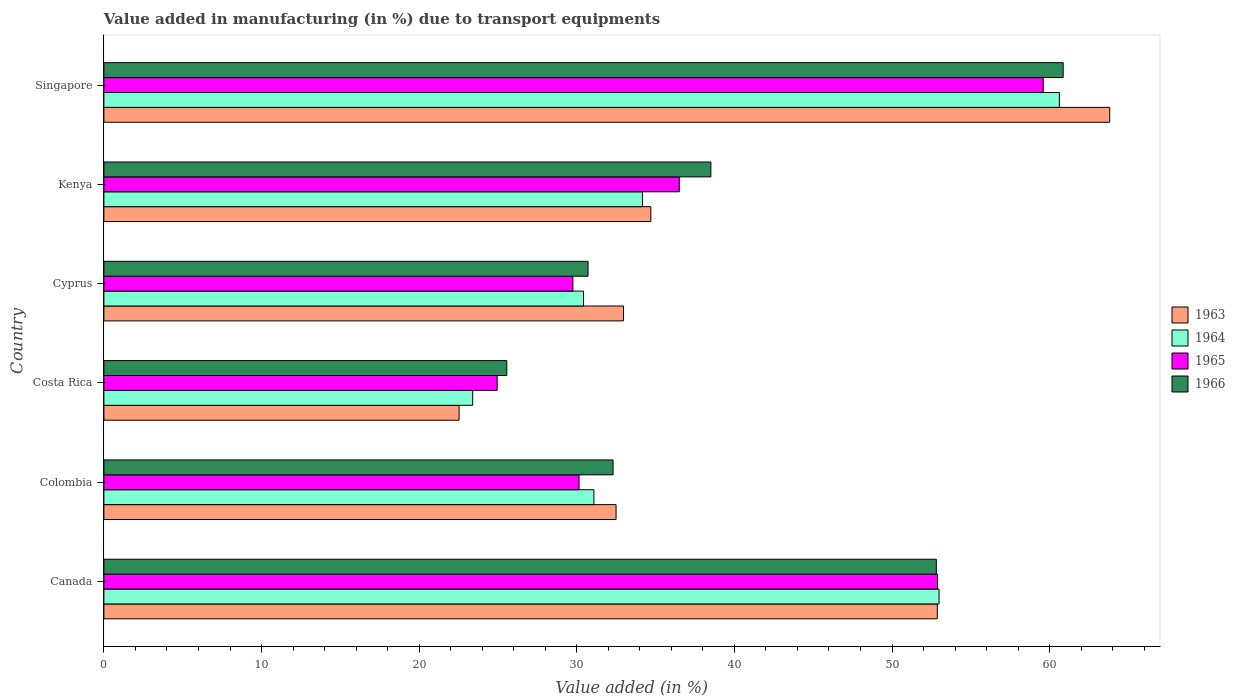Are the number of bars per tick equal to the number of legend labels?
Offer a terse response. Yes. Are the number of bars on each tick of the Y-axis equal?
Provide a succinct answer. Yes. In how many cases, is the number of bars for a given country not equal to the number of legend labels?
Your response must be concise. 0. What is the percentage of value added in manufacturing due to transport equipments in 1965 in Singapore?
Your answer should be very brief. 59.59. Across all countries, what is the maximum percentage of value added in manufacturing due to transport equipments in 1966?
Ensure brevity in your answer.  60.86. Across all countries, what is the minimum percentage of value added in manufacturing due to transport equipments in 1965?
Offer a very short reply. 24.95. In which country was the percentage of value added in manufacturing due to transport equipments in 1965 maximum?
Offer a very short reply. Singapore. What is the total percentage of value added in manufacturing due to transport equipments in 1964 in the graph?
Provide a succinct answer. 232.68. What is the difference between the percentage of value added in manufacturing due to transport equipments in 1966 in Canada and that in Costa Rica?
Your answer should be very brief. 27.25. What is the difference between the percentage of value added in manufacturing due to transport equipments in 1965 in Cyprus and the percentage of value added in manufacturing due to transport equipments in 1966 in Costa Rica?
Make the answer very short. 4.19. What is the average percentage of value added in manufacturing due to transport equipments in 1964 per country?
Your answer should be compact. 38.78. What is the difference between the percentage of value added in manufacturing due to transport equipments in 1964 and percentage of value added in manufacturing due to transport equipments in 1965 in Singapore?
Give a very brief answer. 1.03. In how many countries, is the percentage of value added in manufacturing due to transport equipments in 1965 greater than 4 %?
Offer a very short reply. 6. What is the ratio of the percentage of value added in manufacturing due to transport equipments in 1964 in Colombia to that in Kenya?
Your answer should be very brief. 0.91. Is the percentage of value added in manufacturing due to transport equipments in 1965 in Canada less than that in Cyprus?
Provide a succinct answer. No. Is the difference between the percentage of value added in manufacturing due to transport equipments in 1964 in Cyprus and Kenya greater than the difference between the percentage of value added in manufacturing due to transport equipments in 1965 in Cyprus and Kenya?
Ensure brevity in your answer.  Yes. What is the difference between the highest and the second highest percentage of value added in manufacturing due to transport equipments in 1964?
Your answer should be compact. 7.63. What is the difference between the highest and the lowest percentage of value added in manufacturing due to transport equipments in 1964?
Keep it short and to the point. 37.22. In how many countries, is the percentage of value added in manufacturing due to transport equipments in 1965 greater than the average percentage of value added in manufacturing due to transport equipments in 1965 taken over all countries?
Your response must be concise. 2. What does the 3rd bar from the bottom in Costa Rica represents?
Your response must be concise. 1965. Is it the case that in every country, the sum of the percentage of value added in manufacturing due to transport equipments in 1964 and percentage of value added in manufacturing due to transport equipments in 1963 is greater than the percentage of value added in manufacturing due to transport equipments in 1965?
Ensure brevity in your answer.  Yes. How many bars are there?
Your response must be concise. 24. Are all the bars in the graph horizontal?
Keep it short and to the point. Yes. Are the values on the major ticks of X-axis written in scientific E-notation?
Give a very brief answer. No. Where does the legend appear in the graph?
Offer a very short reply. Center right. How many legend labels are there?
Ensure brevity in your answer.  4. How are the legend labels stacked?
Offer a very short reply. Vertical. What is the title of the graph?
Provide a short and direct response. Value added in manufacturing (in %) due to transport equipments. What is the label or title of the X-axis?
Ensure brevity in your answer.  Value added (in %). What is the label or title of the Y-axis?
Offer a terse response. Country. What is the Value added (in %) in 1963 in Canada?
Offer a very short reply. 52.87. What is the Value added (in %) in 1964 in Canada?
Make the answer very short. 52.98. What is the Value added (in %) in 1965 in Canada?
Keep it short and to the point. 52.89. What is the Value added (in %) of 1966 in Canada?
Offer a very short reply. 52.81. What is the Value added (in %) of 1963 in Colombia?
Provide a succinct answer. 32.49. What is the Value added (in %) in 1964 in Colombia?
Make the answer very short. 31.09. What is the Value added (in %) of 1965 in Colombia?
Your answer should be very brief. 30.15. What is the Value added (in %) of 1966 in Colombia?
Provide a succinct answer. 32.3. What is the Value added (in %) of 1963 in Costa Rica?
Give a very brief answer. 22.53. What is the Value added (in %) of 1964 in Costa Rica?
Ensure brevity in your answer.  23.4. What is the Value added (in %) in 1965 in Costa Rica?
Offer a terse response. 24.95. What is the Value added (in %) in 1966 in Costa Rica?
Keep it short and to the point. 25.56. What is the Value added (in %) in 1963 in Cyprus?
Make the answer very short. 32.97. What is the Value added (in %) in 1964 in Cyprus?
Provide a short and direct response. 30.43. What is the Value added (in %) of 1965 in Cyprus?
Give a very brief answer. 29.75. What is the Value added (in %) in 1966 in Cyprus?
Provide a succinct answer. 30.72. What is the Value added (in %) of 1963 in Kenya?
Offer a very short reply. 34.7. What is the Value added (in %) of 1964 in Kenya?
Your answer should be compact. 34.17. What is the Value added (in %) in 1965 in Kenya?
Your answer should be very brief. 36.5. What is the Value added (in %) in 1966 in Kenya?
Make the answer very short. 38.51. What is the Value added (in %) in 1963 in Singapore?
Give a very brief answer. 63.81. What is the Value added (in %) in 1964 in Singapore?
Your response must be concise. 60.62. What is the Value added (in %) in 1965 in Singapore?
Give a very brief answer. 59.59. What is the Value added (in %) of 1966 in Singapore?
Offer a very short reply. 60.86. Across all countries, what is the maximum Value added (in %) of 1963?
Offer a terse response. 63.81. Across all countries, what is the maximum Value added (in %) of 1964?
Provide a succinct answer. 60.62. Across all countries, what is the maximum Value added (in %) in 1965?
Offer a terse response. 59.59. Across all countries, what is the maximum Value added (in %) of 1966?
Your answer should be compact. 60.86. Across all countries, what is the minimum Value added (in %) in 1963?
Provide a short and direct response. 22.53. Across all countries, what is the minimum Value added (in %) in 1964?
Make the answer very short. 23.4. Across all countries, what is the minimum Value added (in %) of 1965?
Offer a very short reply. 24.95. Across all countries, what is the minimum Value added (in %) in 1966?
Your answer should be very brief. 25.56. What is the total Value added (in %) in 1963 in the graph?
Your response must be concise. 239.38. What is the total Value added (in %) of 1964 in the graph?
Your answer should be compact. 232.68. What is the total Value added (in %) in 1965 in the graph?
Provide a succinct answer. 233.83. What is the total Value added (in %) in 1966 in the graph?
Provide a succinct answer. 240.76. What is the difference between the Value added (in %) of 1963 in Canada and that in Colombia?
Your answer should be very brief. 20.38. What is the difference between the Value added (in %) in 1964 in Canada and that in Colombia?
Give a very brief answer. 21.9. What is the difference between the Value added (in %) in 1965 in Canada and that in Colombia?
Keep it short and to the point. 22.74. What is the difference between the Value added (in %) in 1966 in Canada and that in Colombia?
Give a very brief answer. 20.51. What is the difference between the Value added (in %) in 1963 in Canada and that in Costa Rica?
Ensure brevity in your answer.  30.34. What is the difference between the Value added (in %) in 1964 in Canada and that in Costa Rica?
Your response must be concise. 29.59. What is the difference between the Value added (in %) of 1965 in Canada and that in Costa Rica?
Your answer should be very brief. 27.93. What is the difference between the Value added (in %) of 1966 in Canada and that in Costa Rica?
Make the answer very short. 27.25. What is the difference between the Value added (in %) of 1963 in Canada and that in Cyprus?
Provide a succinct answer. 19.91. What is the difference between the Value added (in %) of 1964 in Canada and that in Cyprus?
Make the answer very short. 22.55. What is the difference between the Value added (in %) of 1965 in Canada and that in Cyprus?
Your answer should be very brief. 23.13. What is the difference between the Value added (in %) in 1966 in Canada and that in Cyprus?
Offer a very short reply. 22.1. What is the difference between the Value added (in %) in 1963 in Canada and that in Kenya?
Offer a terse response. 18.17. What is the difference between the Value added (in %) in 1964 in Canada and that in Kenya?
Your answer should be compact. 18.81. What is the difference between the Value added (in %) of 1965 in Canada and that in Kenya?
Ensure brevity in your answer.  16.38. What is the difference between the Value added (in %) of 1966 in Canada and that in Kenya?
Ensure brevity in your answer.  14.3. What is the difference between the Value added (in %) in 1963 in Canada and that in Singapore?
Your answer should be compact. -10.94. What is the difference between the Value added (in %) in 1964 in Canada and that in Singapore?
Make the answer very short. -7.63. What is the difference between the Value added (in %) in 1965 in Canada and that in Singapore?
Make the answer very short. -6.71. What is the difference between the Value added (in %) of 1966 in Canada and that in Singapore?
Make the answer very short. -8.05. What is the difference between the Value added (in %) of 1963 in Colombia and that in Costa Rica?
Ensure brevity in your answer.  9.96. What is the difference between the Value added (in %) in 1964 in Colombia and that in Costa Rica?
Ensure brevity in your answer.  7.69. What is the difference between the Value added (in %) in 1965 in Colombia and that in Costa Rica?
Give a very brief answer. 5.2. What is the difference between the Value added (in %) in 1966 in Colombia and that in Costa Rica?
Offer a very short reply. 6.74. What is the difference between the Value added (in %) of 1963 in Colombia and that in Cyprus?
Provide a succinct answer. -0.47. What is the difference between the Value added (in %) of 1964 in Colombia and that in Cyprus?
Give a very brief answer. 0.66. What is the difference between the Value added (in %) in 1965 in Colombia and that in Cyprus?
Your answer should be very brief. 0.39. What is the difference between the Value added (in %) of 1966 in Colombia and that in Cyprus?
Your answer should be very brief. 1.59. What is the difference between the Value added (in %) of 1963 in Colombia and that in Kenya?
Your answer should be very brief. -2.21. What is the difference between the Value added (in %) of 1964 in Colombia and that in Kenya?
Keep it short and to the point. -3.08. What is the difference between the Value added (in %) in 1965 in Colombia and that in Kenya?
Make the answer very short. -6.36. What is the difference between the Value added (in %) of 1966 in Colombia and that in Kenya?
Offer a terse response. -6.2. What is the difference between the Value added (in %) of 1963 in Colombia and that in Singapore?
Provide a short and direct response. -31.32. What is the difference between the Value added (in %) of 1964 in Colombia and that in Singapore?
Give a very brief answer. -29.53. What is the difference between the Value added (in %) in 1965 in Colombia and that in Singapore?
Your answer should be very brief. -29.45. What is the difference between the Value added (in %) in 1966 in Colombia and that in Singapore?
Make the answer very short. -28.56. What is the difference between the Value added (in %) of 1963 in Costa Rica and that in Cyprus?
Your answer should be very brief. -10.43. What is the difference between the Value added (in %) in 1964 in Costa Rica and that in Cyprus?
Your answer should be compact. -7.03. What is the difference between the Value added (in %) in 1965 in Costa Rica and that in Cyprus?
Ensure brevity in your answer.  -4.8. What is the difference between the Value added (in %) of 1966 in Costa Rica and that in Cyprus?
Make the answer very short. -5.16. What is the difference between the Value added (in %) of 1963 in Costa Rica and that in Kenya?
Provide a succinct answer. -12.17. What is the difference between the Value added (in %) in 1964 in Costa Rica and that in Kenya?
Make the answer very short. -10.77. What is the difference between the Value added (in %) in 1965 in Costa Rica and that in Kenya?
Provide a short and direct response. -11.55. What is the difference between the Value added (in %) in 1966 in Costa Rica and that in Kenya?
Make the answer very short. -12.95. What is the difference between the Value added (in %) of 1963 in Costa Rica and that in Singapore?
Your answer should be very brief. -41.28. What is the difference between the Value added (in %) of 1964 in Costa Rica and that in Singapore?
Your answer should be compact. -37.22. What is the difference between the Value added (in %) in 1965 in Costa Rica and that in Singapore?
Offer a very short reply. -34.64. What is the difference between the Value added (in %) of 1966 in Costa Rica and that in Singapore?
Your response must be concise. -35.3. What is the difference between the Value added (in %) of 1963 in Cyprus and that in Kenya?
Provide a short and direct response. -1.73. What is the difference between the Value added (in %) of 1964 in Cyprus and that in Kenya?
Your response must be concise. -3.74. What is the difference between the Value added (in %) in 1965 in Cyprus and that in Kenya?
Offer a terse response. -6.75. What is the difference between the Value added (in %) of 1966 in Cyprus and that in Kenya?
Your answer should be very brief. -7.79. What is the difference between the Value added (in %) of 1963 in Cyprus and that in Singapore?
Ensure brevity in your answer.  -30.84. What is the difference between the Value added (in %) of 1964 in Cyprus and that in Singapore?
Your answer should be very brief. -30.19. What is the difference between the Value added (in %) in 1965 in Cyprus and that in Singapore?
Make the answer very short. -29.84. What is the difference between the Value added (in %) of 1966 in Cyprus and that in Singapore?
Your answer should be compact. -30.14. What is the difference between the Value added (in %) in 1963 in Kenya and that in Singapore?
Keep it short and to the point. -29.11. What is the difference between the Value added (in %) of 1964 in Kenya and that in Singapore?
Ensure brevity in your answer.  -26.45. What is the difference between the Value added (in %) of 1965 in Kenya and that in Singapore?
Your answer should be very brief. -23.09. What is the difference between the Value added (in %) of 1966 in Kenya and that in Singapore?
Your answer should be very brief. -22.35. What is the difference between the Value added (in %) of 1963 in Canada and the Value added (in %) of 1964 in Colombia?
Keep it short and to the point. 21.79. What is the difference between the Value added (in %) of 1963 in Canada and the Value added (in %) of 1965 in Colombia?
Keep it short and to the point. 22.73. What is the difference between the Value added (in %) in 1963 in Canada and the Value added (in %) in 1966 in Colombia?
Give a very brief answer. 20.57. What is the difference between the Value added (in %) of 1964 in Canada and the Value added (in %) of 1965 in Colombia?
Offer a terse response. 22.84. What is the difference between the Value added (in %) of 1964 in Canada and the Value added (in %) of 1966 in Colombia?
Offer a very short reply. 20.68. What is the difference between the Value added (in %) of 1965 in Canada and the Value added (in %) of 1966 in Colombia?
Offer a terse response. 20.58. What is the difference between the Value added (in %) in 1963 in Canada and the Value added (in %) in 1964 in Costa Rica?
Provide a short and direct response. 29.48. What is the difference between the Value added (in %) in 1963 in Canada and the Value added (in %) in 1965 in Costa Rica?
Offer a terse response. 27.92. What is the difference between the Value added (in %) of 1963 in Canada and the Value added (in %) of 1966 in Costa Rica?
Make the answer very short. 27.31. What is the difference between the Value added (in %) in 1964 in Canada and the Value added (in %) in 1965 in Costa Rica?
Ensure brevity in your answer.  28.03. What is the difference between the Value added (in %) in 1964 in Canada and the Value added (in %) in 1966 in Costa Rica?
Keep it short and to the point. 27.42. What is the difference between the Value added (in %) in 1965 in Canada and the Value added (in %) in 1966 in Costa Rica?
Your answer should be very brief. 27.33. What is the difference between the Value added (in %) in 1963 in Canada and the Value added (in %) in 1964 in Cyprus?
Provide a succinct answer. 22.44. What is the difference between the Value added (in %) of 1963 in Canada and the Value added (in %) of 1965 in Cyprus?
Your response must be concise. 23.12. What is the difference between the Value added (in %) in 1963 in Canada and the Value added (in %) in 1966 in Cyprus?
Provide a short and direct response. 22.16. What is the difference between the Value added (in %) in 1964 in Canada and the Value added (in %) in 1965 in Cyprus?
Ensure brevity in your answer.  23.23. What is the difference between the Value added (in %) in 1964 in Canada and the Value added (in %) in 1966 in Cyprus?
Offer a very short reply. 22.27. What is the difference between the Value added (in %) in 1965 in Canada and the Value added (in %) in 1966 in Cyprus?
Offer a very short reply. 22.17. What is the difference between the Value added (in %) of 1963 in Canada and the Value added (in %) of 1964 in Kenya?
Provide a short and direct response. 18.7. What is the difference between the Value added (in %) in 1963 in Canada and the Value added (in %) in 1965 in Kenya?
Your answer should be compact. 16.37. What is the difference between the Value added (in %) in 1963 in Canada and the Value added (in %) in 1966 in Kenya?
Offer a terse response. 14.37. What is the difference between the Value added (in %) of 1964 in Canada and the Value added (in %) of 1965 in Kenya?
Ensure brevity in your answer.  16.48. What is the difference between the Value added (in %) of 1964 in Canada and the Value added (in %) of 1966 in Kenya?
Your answer should be compact. 14.47. What is the difference between the Value added (in %) of 1965 in Canada and the Value added (in %) of 1966 in Kenya?
Your answer should be compact. 14.38. What is the difference between the Value added (in %) of 1963 in Canada and the Value added (in %) of 1964 in Singapore?
Give a very brief answer. -7.74. What is the difference between the Value added (in %) of 1963 in Canada and the Value added (in %) of 1965 in Singapore?
Give a very brief answer. -6.72. What is the difference between the Value added (in %) in 1963 in Canada and the Value added (in %) in 1966 in Singapore?
Ensure brevity in your answer.  -7.99. What is the difference between the Value added (in %) in 1964 in Canada and the Value added (in %) in 1965 in Singapore?
Your answer should be very brief. -6.61. What is the difference between the Value added (in %) of 1964 in Canada and the Value added (in %) of 1966 in Singapore?
Make the answer very short. -7.88. What is the difference between the Value added (in %) of 1965 in Canada and the Value added (in %) of 1966 in Singapore?
Ensure brevity in your answer.  -7.97. What is the difference between the Value added (in %) in 1963 in Colombia and the Value added (in %) in 1964 in Costa Rica?
Your response must be concise. 9.1. What is the difference between the Value added (in %) in 1963 in Colombia and the Value added (in %) in 1965 in Costa Rica?
Keep it short and to the point. 7.54. What is the difference between the Value added (in %) in 1963 in Colombia and the Value added (in %) in 1966 in Costa Rica?
Offer a very short reply. 6.93. What is the difference between the Value added (in %) in 1964 in Colombia and the Value added (in %) in 1965 in Costa Rica?
Provide a short and direct response. 6.14. What is the difference between the Value added (in %) of 1964 in Colombia and the Value added (in %) of 1966 in Costa Rica?
Give a very brief answer. 5.53. What is the difference between the Value added (in %) in 1965 in Colombia and the Value added (in %) in 1966 in Costa Rica?
Offer a very short reply. 4.59. What is the difference between the Value added (in %) in 1963 in Colombia and the Value added (in %) in 1964 in Cyprus?
Provide a short and direct response. 2.06. What is the difference between the Value added (in %) of 1963 in Colombia and the Value added (in %) of 1965 in Cyprus?
Give a very brief answer. 2.74. What is the difference between the Value added (in %) of 1963 in Colombia and the Value added (in %) of 1966 in Cyprus?
Provide a short and direct response. 1.78. What is the difference between the Value added (in %) of 1964 in Colombia and the Value added (in %) of 1965 in Cyprus?
Your answer should be compact. 1.33. What is the difference between the Value added (in %) of 1964 in Colombia and the Value added (in %) of 1966 in Cyprus?
Give a very brief answer. 0.37. What is the difference between the Value added (in %) of 1965 in Colombia and the Value added (in %) of 1966 in Cyprus?
Offer a terse response. -0.57. What is the difference between the Value added (in %) of 1963 in Colombia and the Value added (in %) of 1964 in Kenya?
Your answer should be very brief. -1.68. What is the difference between the Value added (in %) of 1963 in Colombia and the Value added (in %) of 1965 in Kenya?
Offer a terse response. -4.01. What is the difference between the Value added (in %) of 1963 in Colombia and the Value added (in %) of 1966 in Kenya?
Your response must be concise. -6.01. What is the difference between the Value added (in %) in 1964 in Colombia and the Value added (in %) in 1965 in Kenya?
Provide a succinct answer. -5.42. What is the difference between the Value added (in %) in 1964 in Colombia and the Value added (in %) in 1966 in Kenya?
Your answer should be very brief. -7.42. What is the difference between the Value added (in %) of 1965 in Colombia and the Value added (in %) of 1966 in Kenya?
Ensure brevity in your answer.  -8.36. What is the difference between the Value added (in %) of 1963 in Colombia and the Value added (in %) of 1964 in Singapore?
Provide a short and direct response. -28.12. What is the difference between the Value added (in %) of 1963 in Colombia and the Value added (in %) of 1965 in Singapore?
Your answer should be compact. -27.1. What is the difference between the Value added (in %) in 1963 in Colombia and the Value added (in %) in 1966 in Singapore?
Give a very brief answer. -28.37. What is the difference between the Value added (in %) in 1964 in Colombia and the Value added (in %) in 1965 in Singapore?
Your response must be concise. -28.51. What is the difference between the Value added (in %) of 1964 in Colombia and the Value added (in %) of 1966 in Singapore?
Your response must be concise. -29.77. What is the difference between the Value added (in %) of 1965 in Colombia and the Value added (in %) of 1966 in Singapore?
Ensure brevity in your answer.  -30.71. What is the difference between the Value added (in %) in 1963 in Costa Rica and the Value added (in %) in 1964 in Cyprus?
Provide a succinct answer. -7.9. What is the difference between the Value added (in %) in 1963 in Costa Rica and the Value added (in %) in 1965 in Cyprus?
Your answer should be very brief. -7.22. What is the difference between the Value added (in %) in 1963 in Costa Rica and the Value added (in %) in 1966 in Cyprus?
Your answer should be very brief. -8.18. What is the difference between the Value added (in %) of 1964 in Costa Rica and the Value added (in %) of 1965 in Cyprus?
Your answer should be compact. -6.36. What is the difference between the Value added (in %) of 1964 in Costa Rica and the Value added (in %) of 1966 in Cyprus?
Your answer should be very brief. -7.32. What is the difference between the Value added (in %) of 1965 in Costa Rica and the Value added (in %) of 1966 in Cyprus?
Offer a terse response. -5.77. What is the difference between the Value added (in %) of 1963 in Costa Rica and the Value added (in %) of 1964 in Kenya?
Offer a very short reply. -11.64. What is the difference between the Value added (in %) of 1963 in Costa Rica and the Value added (in %) of 1965 in Kenya?
Offer a terse response. -13.97. What is the difference between the Value added (in %) in 1963 in Costa Rica and the Value added (in %) in 1966 in Kenya?
Your response must be concise. -15.97. What is the difference between the Value added (in %) of 1964 in Costa Rica and the Value added (in %) of 1965 in Kenya?
Keep it short and to the point. -13.11. What is the difference between the Value added (in %) of 1964 in Costa Rica and the Value added (in %) of 1966 in Kenya?
Your answer should be very brief. -15.11. What is the difference between the Value added (in %) of 1965 in Costa Rica and the Value added (in %) of 1966 in Kenya?
Keep it short and to the point. -13.56. What is the difference between the Value added (in %) of 1963 in Costa Rica and the Value added (in %) of 1964 in Singapore?
Provide a succinct answer. -38.08. What is the difference between the Value added (in %) of 1963 in Costa Rica and the Value added (in %) of 1965 in Singapore?
Your answer should be compact. -37.06. What is the difference between the Value added (in %) in 1963 in Costa Rica and the Value added (in %) in 1966 in Singapore?
Give a very brief answer. -38.33. What is the difference between the Value added (in %) in 1964 in Costa Rica and the Value added (in %) in 1965 in Singapore?
Give a very brief answer. -36.19. What is the difference between the Value added (in %) of 1964 in Costa Rica and the Value added (in %) of 1966 in Singapore?
Your answer should be compact. -37.46. What is the difference between the Value added (in %) of 1965 in Costa Rica and the Value added (in %) of 1966 in Singapore?
Offer a very short reply. -35.91. What is the difference between the Value added (in %) in 1963 in Cyprus and the Value added (in %) in 1964 in Kenya?
Your response must be concise. -1.2. What is the difference between the Value added (in %) in 1963 in Cyprus and the Value added (in %) in 1965 in Kenya?
Provide a succinct answer. -3.54. What is the difference between the Value added (in %) of 1963 in Cyprus and the Value added (in %) of 1966 in Kenya?
Offer a terse response. -5.54. What is the difference between the Value added (in %) of 1964 in Cyprus and the Value added (in %) of 1965 in Kenya?
Give a very brief answer. -6.07. What is the difference between the Value added (in %) in 1964 in Cyprus and the Value added (in %) in 1966 in Kenya?
Offer a terse response. -8.08. What is the difference between the Value added (in %) in 1965 in Cyprus and the Value added (in %) in 1966 in Kenya?
Make the answer very short. -8.75. What is the difference between the Value added (in %) of 1963 in Cyprus and the Value added (in %) of 1964 in Singapore?
Offer a terse response. -27.65. What is the difference between the Value added (in %) in 1963 in Cyprus and the Value added (in %) in 1965 in Singapore?
Make the answer very short. -26.62. What is the difference between the Value added (in %) in 1963 in Cyprus and the Value added (in %) in 1966 in Singapore?
Ensure brevity in your answer.  -27.89. What is the difference between the Value added (in %) in 1964 in Cyprus and the Value added (in %) in 1965 in Singapore?
Offer a terse response. -29.16. What is the difference between the Value added (in %) of 1964 in Cyprus and the Value added (in %) of 1966 in Singapore?
Your response must be concise. -30.43. What is the difference between the Value added (in %) in 1965 in Cyprus and the Value added (in %) in 1966 in Singapore?
Offer a terse response. -31.11. What is the difference between the Value added (in %) of 1963 in Kenya and the Value added (in %) of 1964 in Singapore?
Ensure brevity in your answer.  -25.92. What is the difference between the Value added (in %) of 1963 in Kenya and the Value added (in %) of 1965 in Singapore?
Provide a short and direct response. -24.89. What is the difference between the Value added (in %) in 1963 in Kenya and the Value added (in %) in 1966 in Singapore?
Offer a very short reply. -26.16. What is the difference between the Value added (in %) of 1964 in Kenya and the Value added (in %) of 1965 in Singapore?
Your answer should be compact. -25.42. What is the difference between the Value added (in %) of 1964 in Kenya and the Value added (in %) of 1966 in Singapore?
Make the answer very short. -26.69. What is the difference between the Value added (in %) in 1965 in Kenya and the Value added (in %) in 1966 in Singapore?
Your response must be concise. -24.36. What is the average Value added (in %) in 1963 per country?
Your answer should be very brief. 39.9. What is the average Value added (in %) in 1964 per country?
Provide a succinct answer. 38.78. What is the average Value added (in %) in 1965 per country?
Provide a short and direct response. 38.97. What is the average Value added (in %) of 1966 per country?
Offer a terse response. 40.13. What is the difference between the Value added (in %) of 1963 and Value added (in %) of 1964 in Canada?
Offer a terse response. -0.11. What is the difference between the Value added (in %) in 1963 and Value added (in %) in 1965 in Canada?
Keep it short and to the point. -0.01. What is the difference between the Value added (in %) of 1963 and Value added (in %) of 1966 in Canada?
Keep it short and to the point. 0.06. What is the difference between the Value added (in %) of 1964 and Value added (in %) of 1965 in Canada?
Ensure brevity in your answer.  0.1. What is the difference between the Value added (in %) in 1964 and Value added (in %) in 1966 in Canada?
Provide a short and direct response. 0.17. What is the difference between the Value added (in %) in 1965 and Value added (in %) in 1966 in Canada?
Offer a terse response. 0.07. What is the difference between the Value added (in %) in 1963 and Value added (in %) in 1964 in Colombia?
Keep it short and to the point. 1.41. What is the difference between the Value added (in %) in 1963 and Value added (in %) in 1965 in Colombia?
Ensure brevity in your answer.  2.35. What is the difference between the Value added (in %) of 1963 and Value added (in %) of 1966 in Colombia?
Offer a very short reply. 0.19. What is the difference between the Value added (in %) in 1964 and Value added (in %) in 1965 in Colombia?
Provide a succinct answer. 0.94. What is the difference between the Value added (in %) of 1964 and Value added (in %) of 1966 in Colombia?
Provide a short and direct response. -1.22. What is the difference between the Value added (in %) in 1965 and Value added (in %) in 1966 in Colombia?
Make the answer very short. -2.16. What is the difference between the Value added (in %) in 1963 and Value added (in %) in 1964 in Costa Rica?
Give a very brief answer. -0.86. What is the difference between the Value added (in %) in 1963 and Value added (in %) in 1965 in Costa Rica?
Provide a short and direct response. -2.42. What is the difference between the Value added (in %) of 1963 and Value added (in %) of 1966 in Costa Rica?
Your answer should be very brief. -3.03. What is the difference between the Value added (in %) of 1964 and Value added (in %) of 1965 in Costa Rica?
Give a very brief answer. -1.55. What is the difference between the Value added (in %) in 1964 and Value added (in %) in 1966 in Costa Rica?
Give a very brief answer. -2.16. What is the difference between the Value added (in %) in 1965 and Value added (in %) in 1966 in Costa Rica?
Make the answer very short. -0.61. What is the difference between the Value added (in %) of 1963 and Value added (in %) of 1964 in Cyprus?
Give a very brief answer. 2.54. What is the difference between the Value added (in %) in 1963 and Value added (in %) in 1965 in Cyprus?
Provide a succinct answer. 3.21. What is the difference between the Value added (in %) in 1963 and Value added (in %) in 1966 in Cyprus?
Provide a short and direct response. 2.25. What is the difference between the Value added (in %) of 1964 and Value added (in %) of 1965 in Cyprus?
Your response must be concise. 0.68. What is the difference between the Value added (in %) in 1964 and Value added (in %) in 1966 in Cyprus?
Offer a terse response. -0.29. What is the difference between the Value added (in %) of 1965 and Value added (in %) of 1966 in Cyprus?
Make the answer very short. -0.96. What is the difference between the Value added (in %) of 1963 and Value added (in %) of 1964 in Kenya?
Your response must be concise. 0.53. What is the difference between the Value added (in %) of 1963 and Value added (in %) of 1965 in Kenya?
Provide a short and direct response. -1.8. What is the difference between the Value added (in %) of 1963 and Value added (in %) of 1966 in Kenya?
Give a very brief answer. -3.81. What is the difference between the Value added (in %) in 1964 and Value added (in %) in 1965 in Kenya?
Your answer should be compact. -2.33. What is the difference between the Value added (in %) of 1964 and Value added (in %) of 1966 in Kenya?
Keep it short and to the point. -4.34. What is the difference between the Value added (in %) of 1965 and Value added (in %) of 1966 in Kenya?
Your response must be concise. -2. What is the difference between the Value added (in %) in 1963 and Value added (in %) in 1964 in Singapore?
Give a very brief answer. 3.19. What is the difference between the Value added (in %) in 1963 and Value added (in %) in 1965 in Singapore?
Your answer should be compact. 4.22. What is the difference between the Value added (in %) in 1963 and Value added (in %) in 1966 in Singapore?
Ensure brevity in your answer.  2.95. What is the difference between the Value added (in %) in 1964 and Value added (in %) in 1965 in Singapore?
Your answer should be very brief. 1.03. What is the difference between the Value added (in %) in 1964 and Value added (in %) in 1966 in Singapore?
Offer a terse response. -0.24. What is the difference between the Value added (in %) of 1965 and Value added (in %) of 1966 in Singapore?
Provide a succinct answer. -1.27. What is the ratio of the Value added (in %) in 1963 in Canada to that in Colombia?
Ensure brevity in your answer.  1.63. What is the ratio of the Value added (in %) of 1964 in Canada to that in Colombia?
Your response must be concise. 1.7. What is the ratio of the Value added (in %) in 1965 in Canada to that in Colombia?
Ensure brevity in your answer.  1.75. What is the ratio of the Value added (in %) of 1966 in Canada to that in Colombia?
Provide a short and direct response. 1.63. What is the ratio of the Value added (in %) in 1963 in Canada to that in Costa Rica?
Provide a succinct answer. 2.35. What is the ratio of the Value added (in %) in 1964 in Canada to that in Costa Rica?
Provide a short and direct response. 2.26. What is the ratio of the Value added (in %) in 1965 in Canada to that in Costa Rica?
Offer a terse response. 2.12. What is the ratio of the Value added (in %) of 1966 in Canada to that in Costa Rica?
Your answer should be very brief. 2.07. What is the ratio of the Value added (in %) of 1963 in Canada to that in Cyprus?
Provide a succinct answer. 1.6. What is the ratio of the Value added (in %) of 1964 in Canada to that in Cyprus?
Keep it short and to the point. 1.74. What is the ratio of the Value added (in %) in 1965 in Canada to that in Cyprus?
Your response must be concise. 1.78. What is the ratio of the Value added (in %) in 1966 in Canada to that in Cyprus?
Give a very brief answer. 1.72. What is the ratio of the Value added (in %) in 1963 in Canada to that in Kenya?
Make the answer very short. 1.52. What is the ratio of the Value added (in %) in 1964 in Canada to that in Kenya?
Offer a very short reply. 1.55. What is the ratio of the Value added (in %) in 1965 in Canada to that in Kenya?
Your response must be concise. 1.45. What is the ratio of the Value added (in %) of 1966 in Canada to that in Kenya?
Provide a succinct answer. 1.37. What is the ratio of the Value added (in %) in 1963 in Canada to that in Singapore?
Make the answer very short. 0.83. What is the ratio of the Value added (in %) of 1964 in Canada to that in Singapore?
Your response must be concise. 0.87. What is the ratio of the Value added (in %) in 1965 in Canada to that in Singapore?
Offer a very short reply. 0.89. What is the ratio of the Value added (in %) of 1966 in Canada to that in Singapore?
Provide a succinct answer. 0.87. What is the ratio of the Value added (in %) in 1963 in Colombia to that in Costa Rica?
Provide a succinct answer. 1.44. What is the ratio of the Value added (in %) in 1964 in Colombia to that in Costa Rica?
Your answer should be very brief. 1.33. What is the ratio of the Value added (in %) in 1965 in Colombia to that in Costa Rica?
Your answer should be very brief. 1.21. What is the ratio of the Value added (in %) in 1966 in Colombia to that in Costa Rica?
Your answer should be very brief. 1.26. What is the ratio of the Value added (in %) in 1963 in Colombia to that in Cyprus?
Offer a very short reply. 0.99. What is the ratio of the Value added (in %) of 1964 in Colombia to that in Cyprus?
Offer a terse response. 1.02. What is the ratio of the Value added (in %) in 1965 in Colombia to that in Cyprus?
Provide a succinct answer. 1.01. What is the ratio of the Value added (in %) of 1966 in Colombia to that in Cyprus?
Your response must be concise. 1.05. What is the ratio of the Value added (in %) of 1963 in Colombia to that in Kenya?
Give a very brief answer. 0.94. What is the ratio of the Value added (in %) of 1964 in Colombia to that in Kenya?
Your answer should be compact. 0.91. What is the ratio of the Value added (in %) in 1965 in Colombia to that in Kenya?
Keep it short and to the point. 0.83. What is the ratio of the Value added (in %) of 1966 in Colombia to that in Kenya?
Offer a terse response. 0.84. What is the ratio of the Value added (in %) of 1963 in Colombia to that in Singapore?
Provide a succinct answer. 0.51. What is the ratio of the Value added (in %) in 1964 in Colombia to that in Singapore?
Provide a succinct answer. 0.51. What is the ratio of the Value added (in %) of 1965 in Colombia to that in Singapore?
Ensure brevity in your answer.  0.51. What is the ratio of the Value added (in %) in 1966 in Colombia to that in Singapore?
Offer a very short reply. 0.53. What is the ratio of the Value added (in %) of 1963 in Costa Rica to that in Cyprus?
Your response must be concise. 0.68. What is the ratio of the Value added (in %) of 1964 in Costa Rica to that in Cyprus?
Your response must be concise. 0.77. What is the ratio of the Value added (in %) of 1965 in Costa Rica to that in Cyprus?
Your response must be concise. 0.84. What is the ratio of the Value added (in %) in 1966 in Costa Rica to that in Cyprus?
Your answer should be very brief. 0.83. What is the ratio of the Value added (in %) of 1963 in Costa Rica to that in Kenya?
Ensure brevity in your answer.  0.65. What is the ratio of the Value added (in %) in 1964 in Costa Rica to that in Kenya?
Provide a succinct answer. 0.68. What is the ratio of the Value added (in %) in 1965 in Costa Rica to that in Kenya?
Your answer should be very brief. 0.68. What is the ratio of the Value added (in %) of 1966 in Costa Rica to that in Kenya?
Your answer should be compact. 0.66. What is the ratio of the Value added (in %) in 1963 in Costa Rica to that in Singapore?
Offer a terse response. 0.35. What is the ratio of the Value added (in %) of 1964 in Costa Rica to that in Singapore?
Make the answer very short. 0.39. What is the ratio of the Value added (in %) in 1965 in Costa Rica to that in Singapore?
Provide a short and direct response. 0.42. What is the ratio of the Value added (in %) in 1966 in Costa Rica to that in Singapore?
Offer a terse response. 0.42. What is the ratio of the Value added (in %) of 1963 in Cyprus to that in Kenya?
Make the answer very short. 0.95. What is the ratio of the Value added (in %) in 1964 in Cyprus to that in Kenya?
Offer a terse response. 0.89. What is the ratio of the Value added (in %) of 1965 in Cyprus to that in Kenya?
Provide a succinct answer. 0.82. What is the ratio of the Value added (in %) in 1966 in Cyprus to that in Kenya?
Give a very brief answer. 0.8. What is the ratio of the Value added (in %) of 1963 in Cyprus to that in Singapore?
Your answer should be very brief. 0.52. What is the ratio of the Value added (in %) of 1964 in Cyprus to that in Singapore?
Provide a succinct answer. 0.5. What is the ratio of the Value added (in %) in 1965 in Cyprus to that in Singapore?
Offer a very short reply. 0.5. What is the ratio of the Value added (in %) of 1966 in Cyprus to that in Singapore?
Make the answer very short. 0.5. What is the ratio of the Value added (in %) of 1963 in Kenya to that in Singapore?
Your answer should be compact. 0.54. What is the ratio of the Value added (in %) of 1964 in Kenya to that in Singapore?
Your answer should be compact. 0.56. What is the ratio of the Value added (in %) in 1965 in Kenya to that in Singapore?
Ensure brevity in your answer.  0.61. What is the ratio of the Value added (in %) in 1966 in Kenya to that in Singapore?
Your answer should be very brief. 0.63. What is the difference between the highest and the second highest Value added (in %) in 1963?
Make the answer very short. 10.94. What is the difference between the highest and the second highest Value added (in %) in 1964?
Your answer should be very brief. 7.63. What is the difference between the highest and the second highest Value added (in %) in 1965?
Your response must be concise. 6.71. What is the difference between the highest and the second highest Value added (in %) of 1966?
Offer a terse response. 8.05. What is the difference between the highest and the lowest Value added (in %) of 1963?
Offer a very short reply. 41.28. What is the difference between the highest and the lowest Value added (in %) of 1964?
Your answer should be very brief. 37.22. What is the difference between the highest and the lowest Value added (in %) in 1965?
Offer a terse response. 34.64. What is the difference between the highest and the lowest Value added (in %) of 1966?
Your answer should be very brief. 35.3. 